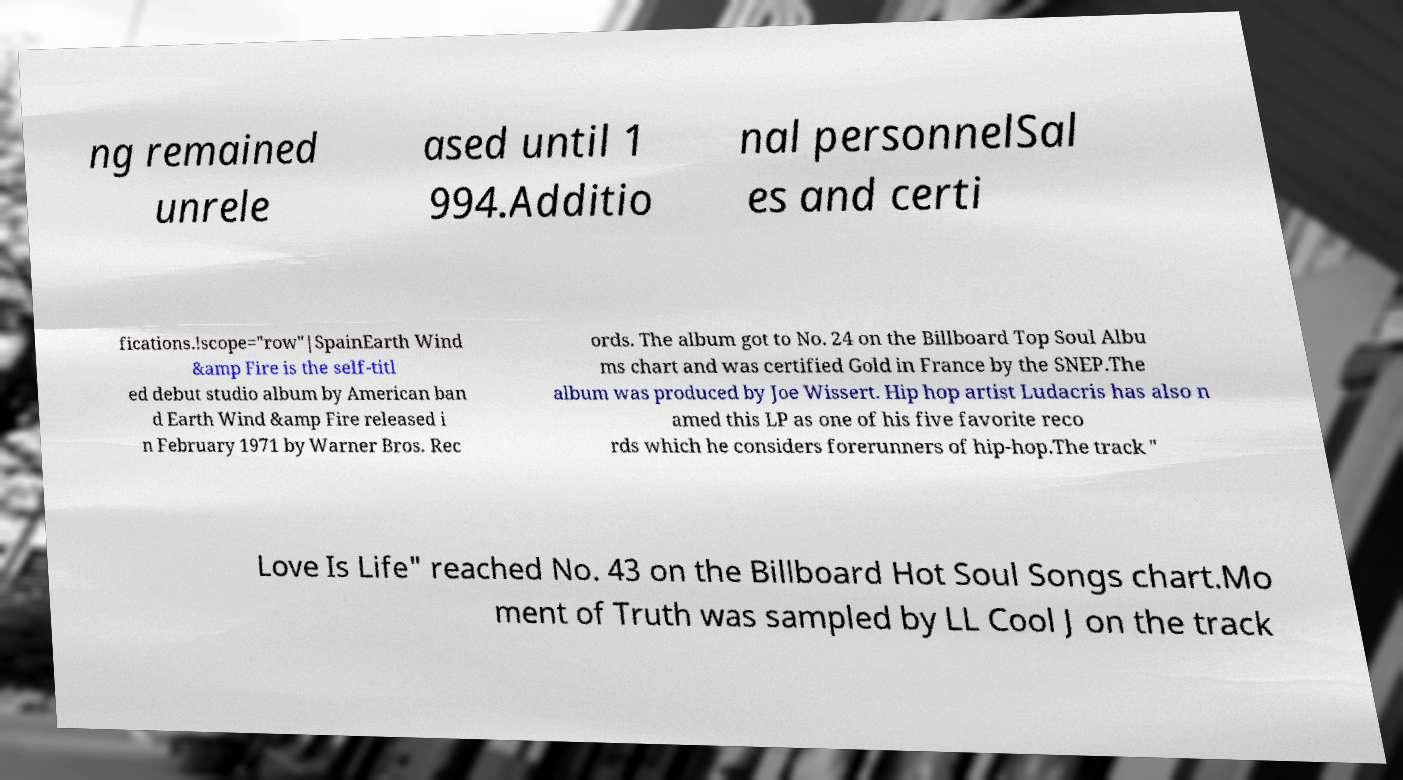Please identify and transcribe the text found in this image. ng remained unrele ased until 1 994.Additio nal personnelSal es and certi fications.!scope="row"|SpainEarth Wind &amp Fire is the self-titl ed debut studio album by American ban d Earth Wind &amp Fire released i n February 1971 by Warner Bros. Rec ords. The album got to No. 24 on the Billboard Top Soul Albu ms chart and was certified Gold in France by the SNEP.The album was produced by Joe Wissert. Hip hop artist Ludacris has also n amed this LP as one of his five favorite reco rds which he considers forerunners of hip-hop.The track " Love Is Life" reached No. 43 on the Billboard Hot Soul Songs chart.Mo ment of Truth was sampled by LL Cool J on the track 